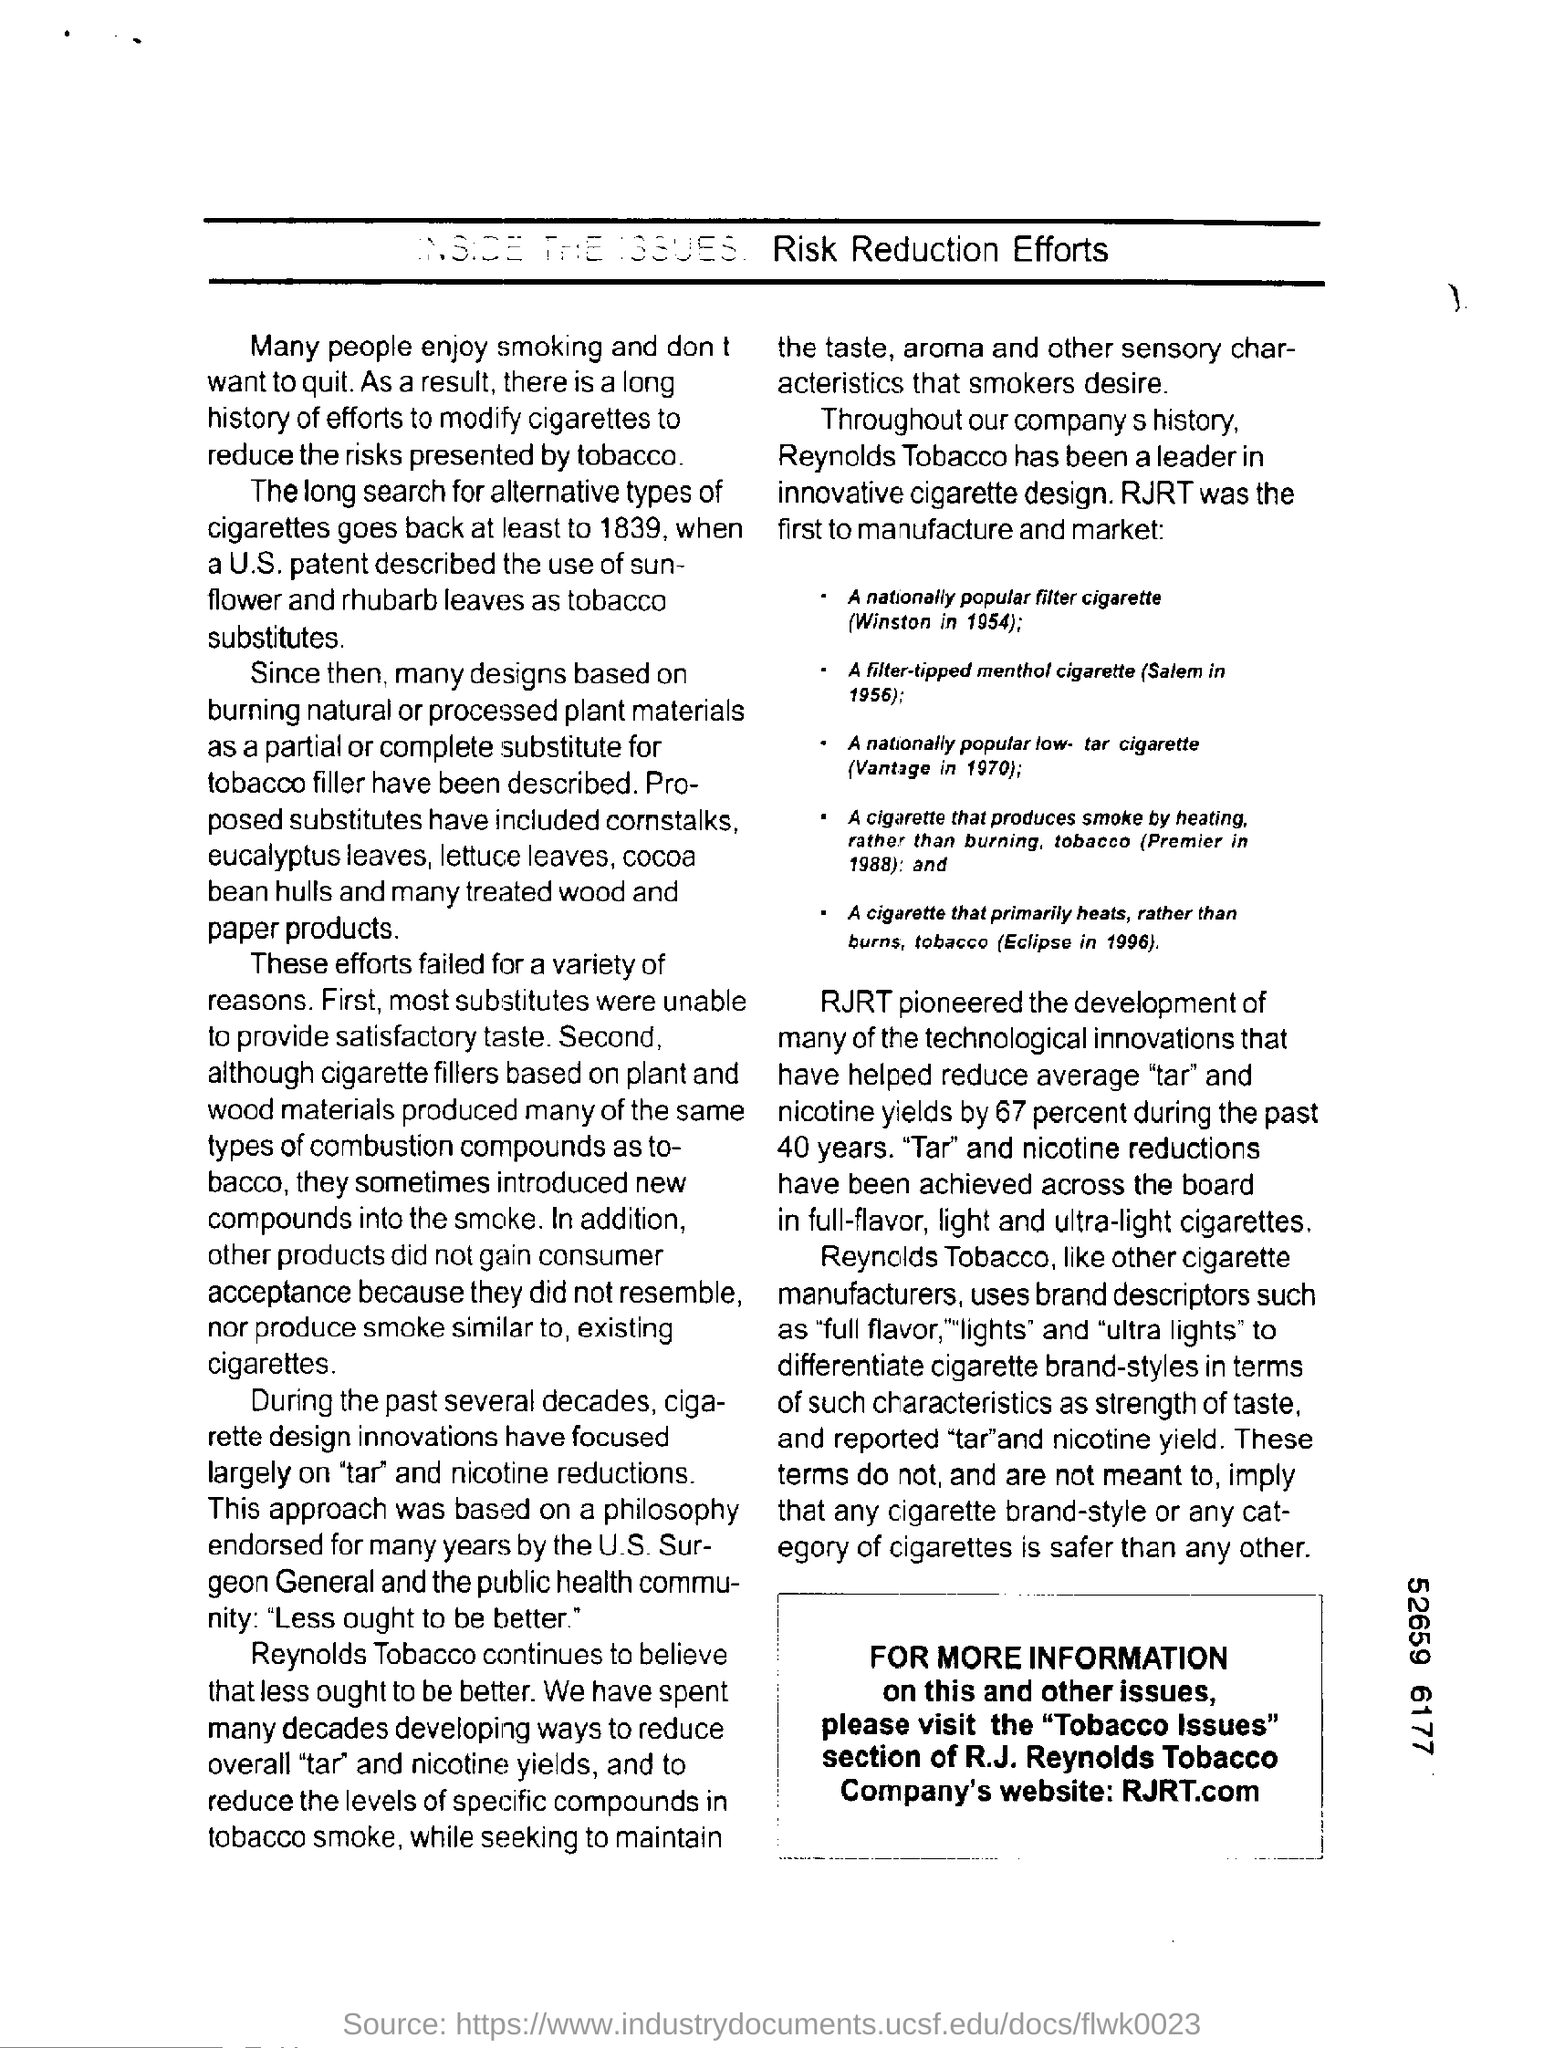Over the past years innovations in cigarette design are primairly focused on what?
Your response must be concise. "tar" and nicotine reductions. As per the u.s. patent what leaves can be used as tobacco substitutes?
Keep it short and to the point. Sunflower and rhubarb leaves. What is the first reason these efforts failed?
Provide a succinct answer. Unable to provide satisfactory tase. IN WHICH YEAR DID RJRT MANUFACTURE NATIONALLY POPULAR FILTER CIGARETTE?
Offer a terse response. 1954. WHO WAS THE LEADER IN INNOVATIVE CIGARETTE DESIGN?
Your answer should be compact. REYNOLDS TOBACCO. Which cigarette of RJRT produces smoke by heating rather than burning, tobacco?
Provide a succinct answer. (Premier in 1988):. WHICH SECTION SHOULD BE VISITED FOR MORE INFORMATION?
Provide a short and direct response. Tobacco Issues. WHAT IS THE COMPANY WEBSITE OF RJRT?
Offer a terse response. RJRT.com. 